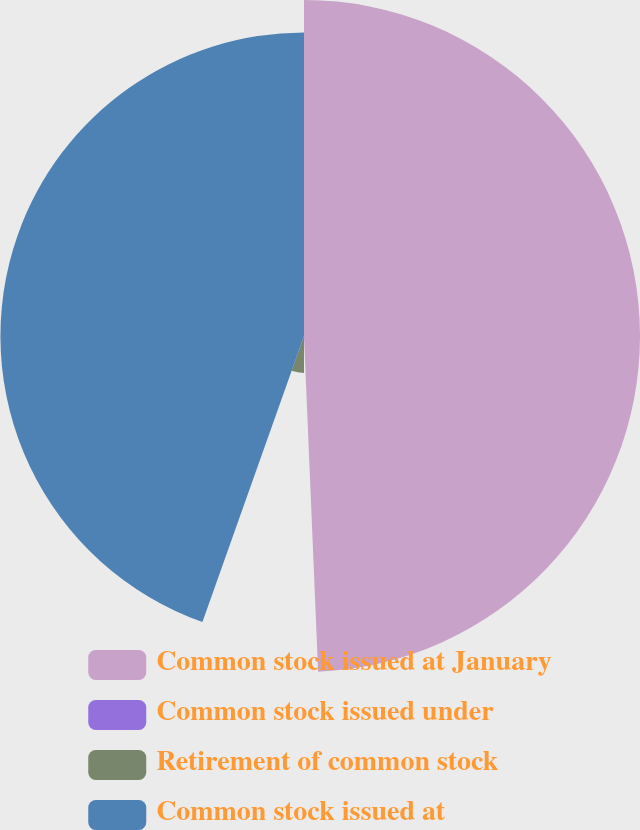<chart> <loc_0><loc_0><loc_500><loc_500><pie_chart><fcel>Common stock issued at January<fcel>Common stock issued under<fcel>Retirement of common stock<fcel>Common stock issued at<nl><fcel>49.33%<fcel>0.67%<fcel>5.43%<fcel>44.57%<nl></chart> 